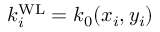<formula> <loc_0><loc_0><loc_500><loc_500>{ k _ { i } ^ { W L } } = k _ { 0 } ( x _ { i } , y _ { i } )</formula> 